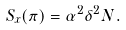Convert formula to latex. <formula><loc_0><loc_0><loc_500><loc_500>S _ { x } ( \pi ) = \alpha ^ { 2 } \delta ^ { 2 } N .</formula> 